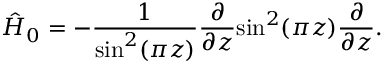<formula> <loc_0><loc_0><loc_500><loc_500>\hat { H } _ { 0 } = - \frac { 1 } { \sin ^ { 2 } ( \pi z ) } \frac { \partial } { \partial z } \sin ^ { 2 } ( \pi z ) \frac { \partial } { \partial z } .</formula> 